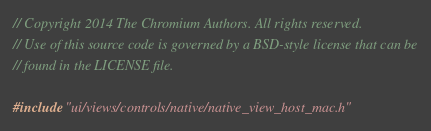<code> <loc_0><loc_0><loc_500><loc_500><_ObjectiveC_>// Copyright 2014 The Chromium Authors. All rights reserved.
// Use of this source code is governed by a BSD-style license that can be
// found in the LICENSE file.

#include "ui/views/controls/native/native_view_host_mac.h"
</code> 